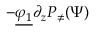<formula> <loc_0><loc_0><loc_500><loc_500>- \underline { { \varphi _ { 1 } } } \partial _ { z } P _ { \neq } ( \Psi )</formula> 